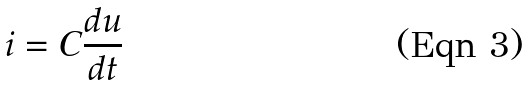<formula> <loc_0><loc_0><loc_500><loc_500>i = C \frac { d u } { d t }</formula> 